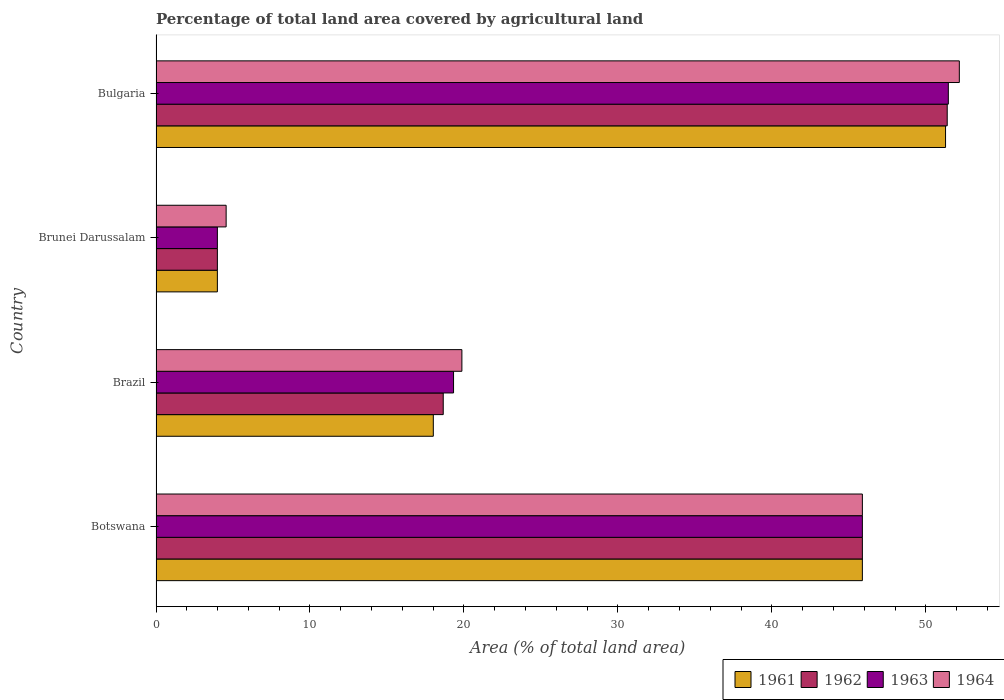How many different coloured bars are there?
Offer a terse response. 4. Are the number of bars per tick equal to the number of legend labels?
Your answer should be very brief. Yes. How many bars are there on the 2nd tick from the top?
Offer a terse response. 4. What is the label of the 1st group of bars from the top?
Provide a succinct answer. Bulgaria. In how many cases, is the number of bars for a given country not equal to the number of legend labels?
Make the answer very short. 0. What is the percentage of agricultural land in 1961 in Brazil?
Offer a very short reply. 18.01. Across all countries, what is the maximum percentage of agricultural land in 1961?
Your answer should be compact. 51.28. Across all countries, what is the minimum percentage of agricultural land in 1963?
Provide a succinct answer. 3.98. In which country was the percentage of agricultural land in 1961 minimum?
Offer a terse response. Brunei Darussalam. What is the total percentage of agricultural land in 1963 in the graph?
Your response must be concise. 120.65. What is the difference between the percentage of agricultural land in 1964 in Brazil and that in Bulgaria?
Ensure brevity in your answer.  -32.31. What is the difference between the percentage of agricultural land in 1964 in Botswana and the percentage of agricultural land in 1961 in Brunei Darussalam?
Your answer should be very brief. 41.89. What is the average percentage of agricultural land in 1963 per country?
Your answer should be very brief. 30.16. What is the difference between the percentage of agricultural land in 1964 and percentage of agricultural land in 1961 in Botswana?
Provide a short and direct response. 0. What is the ratio of the percentage of agricultural land in 1963 in Botswana to that in Bulgaria?
Give a very brief answer. 0.89. What is the difference between the highest and the second highest percentage of agricultural land in 1963?
Make the answer very short. 5.58. What is the difference between the highest and the lowest percentage of agricultural land in 1961?
Your answer should be compact. 47.29. What does the 3rd bar from the top in Bulgaria represents?
Provide a succinct answer. 1962. Is it the case that in every country, the sum of the percentage of agricultural land in 1961 and percentage of agricultural land in 1964 is greater than the percentage of agricultural land in 1962?
Make the answer very short. Yes. How many bars are there?
Your response must be concise. 16. Where does the legend appear in the graph?
Provide a succinct answer. Bottom right. How many legend labels are there?
Offer a very short reply. 4. How are the legend labels stacked?
Ensure brevity in your answer.  Horizontal. What is the title of the graph?
Ensure brevity in your answer.  Percentage of total land area covered by agricultural land. What is the label or title of the X-axis?
Ensure brevity in your answer.  Area (% of total land area). What is the label or title of the Y-axis?
Your answer should be compact. Country. What is the Area (% of total land area) in 1961 in Botswana?
Make the answer very short. 45.88. What is the Area (% of total land area) of 1962 in Botswana?
Your answer should be very brief. 45.88. What is the Area (% of total land area) of 1963 in Botswana?
Your answer should be compact. 45.88. What is the Area (% of total land area) of 1964 in Botswana?
Offer a terse response. 45.88. What is the Area (% of total land area) of 1961 in Brazil?
Give a very brief answer. 18.01. What is the Area (% of total land area) in 1962 in Brazil?
Keep it short and to the point. 18.65. What is the Area (% of total land area) in 1963 in Brazil?
Keep it short and to the point. 19.32. What is the Area (% of total land area) of 1964 in Brazil?
Ensure brevity in your answer.  19.87. What is the Area (% of total land area) in 1961 in Brunei Darussalam?
Offer a very short reply. 3.98. What is the Area (% of total land area) of 1962 in Brunei Darussalam?
Your response must be concise. 3.98. What is the Area (% of total land area) of 1963 in Brunei Darussalam?
Give a very brief answer. 3.98. What is the Area (% of total land area) of 1964 in Brunei Darussalam?
Your response must be concise. 4.55. What is the Area (% of total land area) in 1961 in Bulgaria?
Your response must be concise. 51.28. What is the Area (% of total land area) of 1962 in Bulgaria?
Keep it short and to the point. 51.39. What is the Area (% of total land area) in 1963 in Bulgaria?
Your answer should be compact. 51.46. What is the Area (% of total land area) in 1964 in Bulgaria?
Make the answer very short. 52.17. Across all countries, what is the maximum Area (% of total land area) in 1961?
Provide a succinct answer. 51.28. Across all countries, what is the maximum Area (% of total land area) of 1962?
Offer a very short reply. 51.39. Across all countries, what is the maximum Area (% of total land area) of 1963?
Provide a succinct answer. 51.46. Across all countries, what is the maximum Area (% of total land area) in 1964?
Your answer should be very brief. 52.17. Across all countries, what is the minimum Area (% of total land area) of 1961?
Keep it short and to the point. 3.98. Across all countries, what is the minimum Area (% of total land area) of 1962?
Your answer should be compact. 3.98. Across all countries, what is the minimum Area (% of total land area) in 1963?
Your answer should be very brief. 3.98. Across all countries, what is the minimum Area (% of total land area) of 1964?
Your response must be concise. 4.55. What is the total Area (% of total land area) in 1961 in the graph?
Offer a very short reply. 119.15. What is the total Area (% of total land area) of 1962 in the graph?
Provide a succinct answer. 119.9. What is the total Area (% of total land area) of 1963 in the graph?
Your response must be concise. 120.65. What is the total Area (% of total land area) in 1964 in the graph?
Ensure brevity in your answer.  122.47. What is the difference between the Area (% of total land area) of 1961 in Botswana and that in Brazil?
Ensure brevity in your answer.  27.87. What is the difference between the Area (% of total land area) in 1962 in Botswana and that in Brazil?
Give a very brief answer. 27.22. What is the difference between the Area (% of total land area) in 1963 in Botswana and that in Brazil?
Your answer should be very brief. 26.55. What is the difference between the Area (% of total land area) in 1964 in Botswana and that in Brazil?
Provide a succinct answer. 26.01. What is the difference between the Area (% of total land area) in 1961 in Botswana and that in Brunei Darussalam?
Offer a terse response. 41.89. What is the difference between the Area (% of total land area) in 1962 in Botswana and that in Brunei Darussalam?
Provide a succinct answer. 41.89. What is the difference between the Area (% of total land area) of 1963 in Botswana and that in Brunei Darussalam?
Your answer should be very brief. 41.89. What is the difference between the Area (% of total land area) in 1964 in Botswana and that in Brunei Darussalam?
Your response must be concise. 41.32. What is the difference between the Area (% of total land area) in 1961 in Botswana and that in Bulgaria?
Ensure brevity in your answer.  -5.4. What is the difference between the Area (% of total land area) of 1962 in Botswana and that in Bulgaria?
Offer a very short reply. -5.51. What is the difference between the Area (% of total land area) in 1963 in Botswana and that in Bulgaria?
Make the answer very short. -5.58. What is the difference between the Area (% of total land area) in 1964 in Botswana and that in Bulgaria?
Your answer should be compact. -6.3. What is the difference between the Area (% of total land area) in 1961 in Brazil and that in Brunei Darussalam?
Offer a very short reply. 14.03. What is the difference between the Area (% of total land area) of 1962 in Brazil and that in Brunei Darussalam?
Your response must be concise. 14.67. What is the difference between the Area (% of total land area) in 1963 in Brazil and that in Brunei Darussalam?
Give a very brief answer. 15.34. What is the difference between the Area (% of total land area) in 1964 in Brazil and that in Brunei Darussalam?
Your answer should be compact. 15.31. What is the difference between the Area (% of total land area) in 1961 in Brazil and that in Bulgaria?
Give a very brief answer. -33.27. What is the difference between the Area (% of total land area) of 1962 in Brazil and that in Bulgaria?
Keep it short and to the point. -32.73. What is the difference between the Area (% of total land area) of 1963 in Brazil and that in Bulgaria?
Make the answer very short. -32.14. What is the difference between the Area (% of total land area) of 1964 in Brazil and that in Bulgaria?
Offer a very short reply. -32.31. What is the difference between the Area (% of total land area) of 1961 in Brunei Darussalam and that in Bulgaria?
Make the answer very short. -47.29. What is the difference between the Area (% of total land area) in 1962 in Brunei Darussalam and that in Bulgaria?
Your answer should be very brief. -47.4. What is the difference between the Area (% of total land area) of 1963 in Brunei Darussalam and that in Bulgaria?
Your answer should be compact. -47.48. What is the difference between the Area (% of total land area) of 1964 in Brunei Darussalam and that in Bulgaria?
Ensure brevity in your answer.  -47.62. What is the difference between the Area (% of total land area) in 1961 in Botswana and the Area (% of total land area) in 1962 in Brazil?
Provide a short and direct response. 27.22. What is the difference between the Area (% of total land area) in 1961 in Botswana and the Area (% of total land area) in 1963 in Brazil?
Offer a very short reply. 26.55. What is the difference between the Area (% of total land area) of 1961 in Botswana and the Area (% of total land area) of 1964 in Brazil?
Your answer should be compact. 26.01. What is the difference between the Area (% of total land area) in 1962 in Botswana and the Area (% of total land area) in 1963 in Brazil?
Provide a short and direct response. 26.55. What is the difference between the Area (% of total land area) in 1962 in Botswana and the Area (% of total land area) in 1964 in Brazil?
Provide a short and direct response. 26.01. What is the difference between the Area (% of total land area) of 1963 in Botswana and the Area (% of total land area) of 1964 in Brazil?
Your answer should be very brief. 26.01. What is the difference between the Area (% of total land area) in 1961 in Botswana and the Area (% of total land area) in 1962 in Brunei Darussalam?
Make the answer very short. 41.89. What is the difference between the Area (% of total land area) of 1961 in Botswana and the Area (% of total land area) of 1963 in Brunei Darussalam?
Your response must be concise. 41.89. What is the difference between the Area (% of total land area) in 1961 in Botswana and the Area (% of total land area) in 1964 in Brunei Darussalam?
Offer a terse response. 41.32. What is the difference between the Area (% of total land area) of 1962 in Botswana and the Area (% of total land area) of 1963 in Brunei Darussalam?
Ensure brevity in your answer.  41.89. What is the difference between the Area (% of total land area) in 1962 in Botswana and the Area (% of total land area) in 1964 in Brunei Darussalam?
Your answer should be very brief. 41.32. What is the difference between the Area (% of total land area) in 1963 in Botswana and the Area (% of total land area) in 1964 in Brunei Darussalam?
Keep it short and to the point. 41.32. What is the difference between the Area (% of total land area) in 1961 in Botswana and the Area (% of total land area) in 1962 in Bulgaria?
Keep it short and to the point. -5.51. What is the difference between the Area (% of total land area) in 1961 in Botswana and the Area (% of total land area) in 1963 in Bulgaria?
Ensure brevity in your answer.  -5.58. What is the difference between the Area (% of total land area) in 1961 in Botswana and the Area (% of total land area) in 1964 in Bulgaria?
Make the answer very short. -6.3. What is the difference between the Area (% of total land area) in 1962 in Botswana and the Area (% of total land area) in 1963 in Bulgaria?
Your response must be concise. -5.58. What is the difference between the Area (% of total land area) of 1962 in Botswana and the Area (% of total land area) of 1964 in Bulgaria?
Offer a very short reply. -6.3. What is the difference between the Area (% of total land area) of 1963 in Botswana and the Area (% of total land area) of 1964 in Bulgaria?
Provide a succinct answer. -6.3. What is the difference between the Area (% of total land area) in 1961 in Brazil and the Area (% of total land area) in 1962 in Brunei Darussalam?
Keep it short and to the point. 14.03. What is the difference between the Area (% of total land area) of 1961 in Brazil and the Area (% of total land area) of 1963 in Brunei Darussalam?
Keep it short and to the point. 14.03. What is the difference between the Area (% of total land area) in 1961 in Brazil and the Area (% of total land area) in 1964 in Brunei Darussalam?
Give a very brief answer. 13.46. What is the difference between the Area (% of total land area) in 1962 in Brazil and the Area (% of total land area) in 1963 in Brunei Darussalam?
Keep it short and to the point. 14.67. What is the difference between the Area (% of total land area) in 1963 in Brazil and the Area (% of total land area) in 1964 in Brunei Darussalam?
Keep it short and to the point. 14.77. What is the difference between the Area (% of total land area) of 1961 in Brazil and the Area (% of total land area) of 1962 in Bulgaria?
Your answer should be compact. -33.38. What is the difference between the Area (% of total land area) in 1961 in Brazil and the Area (% of total land area) in 1963 in Bulgaria?
Provide a short and direct response. -33.45. What is the difference between the Area (% of total land area) of 1961 in Brazil and the Area (% of total land area) of 1964 in Bulgaria?
Keep it short and to the point. -34.16. What is the difference between the Area (% of total land area) of 1962 in Brazil and the Area (% of total land area) of 1963 in Bulgaria?
Make the answer very short. -32.81. What is the difference between the Area (% of total land area) in 1962 in Brazil and the Area (% of total land area) in 1964 in Bulgaria?
Ensure brevity in your answer.  -33.52. What is the difference between the Area (% of total land area) of 1963 in Brazil and the Area (% of total land area) of 1964 in Bulgaria?
Ensure brevity in your answer.  -32.85. What is the difference between the Area (% of total land area) of 1961 in Brunei Darussalam and the Area (% of total land area) of 1962 in Bulgaria?
Make the answer very short. -47.4. What is the difference between the Area (% of total land area) in 1961 in Brunei Darussalam and the Area (% of total land area) in 1963 in Bulgaria?
Provide a short and direct response. -47.48. What is the difference between the Area (% of total land area) of 1961 in Brunei Darussalam and the Area (% of total land area) of 1964 in Bulgaria?
Provide a succinct answer. -48.19. What is the difference between the Area (% of total land area) of 1962 in Brunei Darussalam and the Area (% of total land area) of 1963 in Bulgaria?
Provide a succinct answer. -47.48. What is the difference between the Area (% of total land area) in 1962 in Brunei Darussalam and the Area (% of total land area) in 1964 in Bulgaria?
Provide a short and direct response. -48.19. What is the difference between the Area (% of total land area) of 1963 in Brunei Darussalam and the Area (% of total land area) of 1964 in Bulgaria?
Provide a succinct answer. -48.19. What is the average Area (% of total land area) of 1961 per country?
Provide a succinct answer. 29.79. What is the average Area (% of total land area) in 1962 per country?
Offer a terse response. 29.98. What is the average Area (% of total land area) in 1963 per country?
Provide a short and direct response. 30.16. What is the average Area (% of total land area) of 1964 per country?
Offer a terse response. 30.62. What is the difference between the Area (% of total land area) in 1961 and Area (% of total land area) in 1962 in Botswana?
Ensure brevity in your answer.  0. What is the difference between the Area (% of total land area) of 1961 and Area (% of total land area) of 1964 in Botswana?
Provide a short and direct response. 0. What is the difference between the Area (% of total land area) in 1962 and Area (% of total land area) in 1963 in Botswana?
Provide a succinct answer. 0. What is the difference between the Area (% of total land area) of 1963 and Area (% of total land area) of 1964 in Botswana?
Make the answer very short. 0. What is the difference between the Area (% of total land area) of 1961 and Area (% of total land area) of 1962 in Brazil?
Offer a very short reply. -0.64. What is the difference between the Area (% of total land area) in 1961 and Area (% of total land area) in 1963 in Brazil?
Offer a very short reply. -1.31. What is the difference between the Area (% of total land area) in 1961 and Area (% of total land area) in 1964 in Brazil?
Provide a short and direct response. -1.86. What is the difference between the Area (% of total land area) in 1962 and Area (% of total land area) in 1963 in Brazil?
Provide a succinct answer. -0.67. What is the difference between the Area (% of total land area) of 1962 and Area (% of total land area) of 1964 in Brazil?
Give a very brief answer. -1.21. What is the difference between the Area (% of total land area) of 1963 and Area (% of total land area) of 1964 in Brazil?
Provide a succinct answer. -0.54. What is the difference between the Area (% of total land area) in 1961 and Area (% of total land area) in 1962 in Brunei Darussalam?
Make the answer very short. 0. What is the difference between the Area (% of total land area) in 1961 and Area (% of total land area) in 1964 in Brunei Darussalam?
Provide a short and direct response. -0.57. What is the difference between the Area (% of total land area) in 1962 and Area (% of total land area) in 1963 in Brunei Darussalam?
Offer a terse response. 0. What is the difference between the Area (% of total land area) of 1962 and Area (% of total land area) of 1964 in Brunei Darussalam?
Provide a succinct answer. -0.57. What is the difference between the Area (% of total land area) of 1963 and Area (% of total land area) of 1964 in Brunei Darussalam?
Offer a very short reply. -0.57. What is the difference between the Area (% of total land area) in 1961 and Area (% of total land area) in 1962 in Bulgaria?
Keep it short and to the point. -0.11. What is the difference between the Area (% of total land area) of 1961 and Area (% of total land area) of 1963 in Bulgaria?
Provide a short and direct response. -0.18. What is the difference between the Area (% of total land area) of 1961 and Area (% of total land area) of 1964 in Bulgaria?
Give a very brief answer. -0.89. What is the difference between the Area (% of total land area) in 1962 and Area (% of total land area) in 1963 in Bulgaria?
Your answer should be very brief. -0.07. What is the difference between the Area (% of total land area) in 1962 and Area (% of total land area) in 1964 in Bulgaria?
Offer a very short reply. -0.79. What is the difference between the Area (% of total land area) in 1963 and Area (% of total land area) in 1964 in Bulgaria?
Give a very brief answer. -0.71. What is the ratio of the Area (% of total land area) of 1961 in Botswana to that in Brazil?
Provide a short and direct response. 2.55. What is the ratio of the Area (% of total land area) of 1962 in Botswana to that in Brazil?
Give a very brief answer. 2.46. What is the ratio of the Area (% of total land area) in 1963 in Botswana to that in Brazil?
Give a very brief answer. 2.37. What is the ratio of the Area (% of total land area) in 1964 in Botswana to that in Brazil?
Offer a very short reply. 2.31. What is the ratio of the Area (% of total land area) in 1961 in Botswana to that in Brunei Darussalam?
Offer a very short reply. 11.51. What is the ratio of the Area (% of total land area) of 1962 in Botswana to that in Brunei Darussalam?
Offer a very short reply. 11.51. What is the ratio of the Area (% of total land area) in 1963 in Botswana to that in Brunei Darussalam?
Give a very brief answer. 11.51. What is the ratio of the Area (% of total land area) of 1964 in Botswana to that in Brunei Darussalam?
Keep it short and to the point. 10.07. What is the ratio of the Area (% of total land area) in 1961 in Botswana to that in Bulgaria?
Give a very brief answer. 0.89. What is the ratio of the Area (% of total land area) in 1962 in Botswana to that in Bulgaria?
Ensure brevity in your answer.  0.89. What is the ratio of the Area (% of total land area) in 1963 in Botswana to that in Bulgaria?
Provide a short and direct response. 0.89. What is the ratio of the Area (% of total land area) of 1964 in Botswana to that in Bulgaria?
Keep it short and to the point. 0.88. What is the ratio of the Area (% of total land area) in 1961 in Brazil to that in Brunei Darussalam?
Make the answer very short. 4.52. What is the ratio of the Area (% of total land area) in 1962 in Brazil to that in Brunei Darussalam?
Keep it short and to the point. 4.68. What is the ratio of the Area (% of total land area) of 1963 in Brazil to that in Brunei Darussalam?
Provide a short and direct response. 4.85. What is the ratio of the Area (% of total land area) of 1964 in Brazil to that in Brunei Darussalam?
Offer a very short reply. 4.36. What is the ratio of the Area (% of total land area) of 1961 in Brazil to that in Bulgaria?
Your response must be concise. 0.35. What is the ratio of the Area (% of total land area) of 1962 in Brazil to that in Bulgaria?
Your answer should be very brief. 0.36. What is the ratio of the Area (% of total land area) of 1963 in Brazil to that in Bulgaria?
Your response must be concise. 0.38. What is the ratio of the Area (% of total land area) in 1964 in Brazil to that in Bulgaria?
Make the answer very short. 0.38. What is the ratio of the Area (% of total land area) in 1961 in Brunei Darussalam to that in Bulgaria?
Your response must be concise. 0.08. What is the ratio of the Area (% of total land area) in 1962 in Brunei Darussalam to that in Bulgaria?
Your answer should be very brief. 0.08. What is the ratio of the Area (% of total land area) in 1963 in Brunei Darussalam to that in Bulgaria?
Offer a very short reply. 0.08. What is the ratio of the Area (% of total land area) in 1964 in Brunei Darussalam to that in Bulgaria?
Your answer should be very brief. 0.09. What is the difference between the highest and the second highest Area (% of total land area) in 1961?
Provide a succinct answer. 5.4. What is the difference between the highest and the second highest Area (% of total land area) in 1962?
Your answer should be compact. 5.51. What is the difference between the highest and the second highest Area (% of total land area) of 1963?
Ensure brevity in your answer.  5.58. What is the difference between the highest and the second highest Area (% of total land area) in 1964?
Your response must be concise. 6.3. What is the difference between the highest and the lowest Area (% of total land area) of 1961?
Make the answer very short. 47.29. What is the difference between the highest and the lowest Area (% of total land area) of 1962?
Your answer should be compact. 47.4. What is the difference between the highest and the lowest Area (% of total land area) of 1963?
Your response must be concise. 47.48. What is the difference between the highest and the lowest Area (% of total land area) in 1964?
Ensure brevity in your answer.  47.62. 